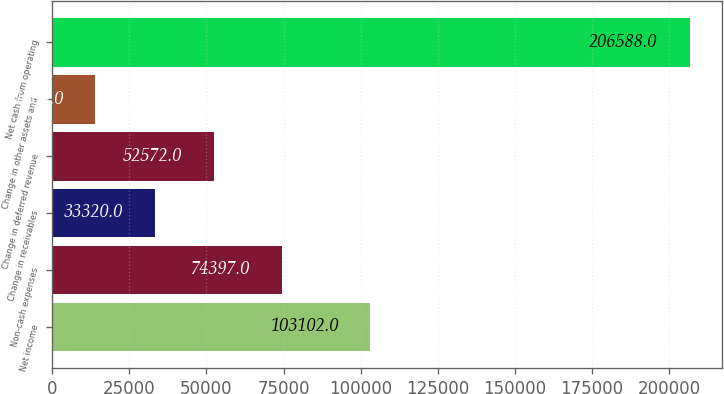<chart> <loc_0><loc_0><loc_500><loc_500><bar_chart><fcel>Net income<fcel>Non-cash expenses<fcel>Change in receivables<fcel>Change in deferred revenue<fcel>Change in other assets and<fcel>Net cash from operating<nl><fcel>103102<fcel>74397<fcel>33320<fcel>52572<fcel>14068<fcel>206588<nl></chart> 